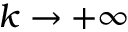Convert formula to latex. <formula><loc_0><loc_0><loc_500><loc_500>k \rightarrow + \infty</formula> 